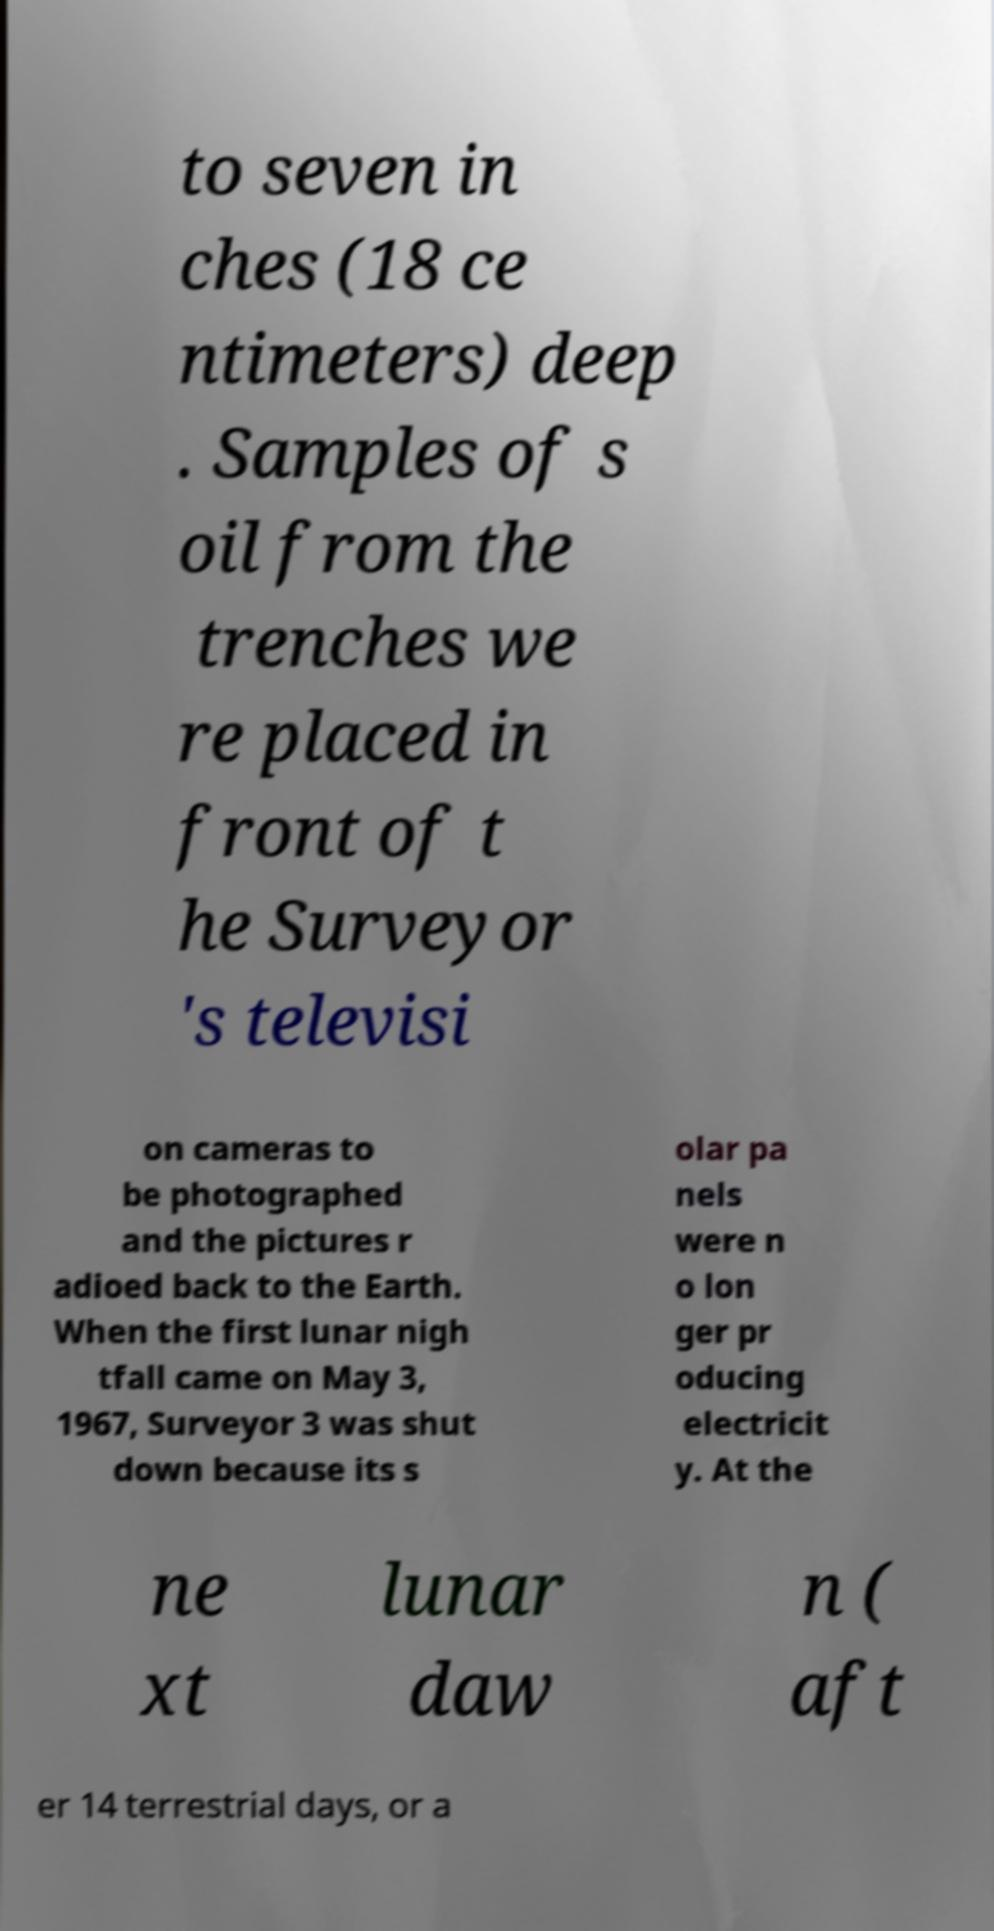I need the written content from this picture converted into text. Can you do that? to seven in ches (18 ce ntimeters) deep . Samples of s oil from the trenches we re placed in front of t he Surveyor 's televisi on cameras to be photographed and the pictures r adioed back to the Earth. When the first lunar nigh tfall came on May 3, 1967, Surveyor 3 was shut down because its s olar pa nels were n o lon ger pr oducing electricit y. At the ne xt lunar daw n ( aft er 14 terrestrial days, or a 